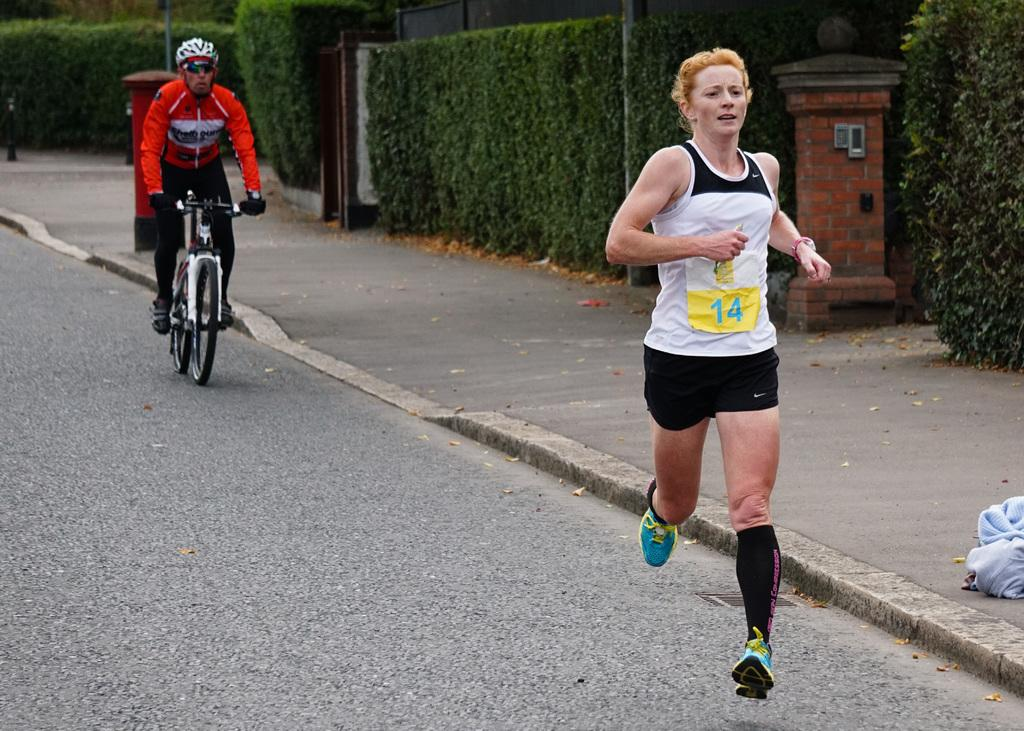How many people are in the image? There are two people in the image. What are the two people doing in the image? One woman is running on the road, and another person is riding a bicycle. What type of vegetation can be seen in the image? There are shrubs visible in the image. What object related to mail can be seen in the image? There is a post box in the image. How many ants can be seen carrying the girl in the image? There are no ants or girls present in the image. What type of dust can be seen covering the bicycle in the image? There is no dust visible on the bicycle in the image. 